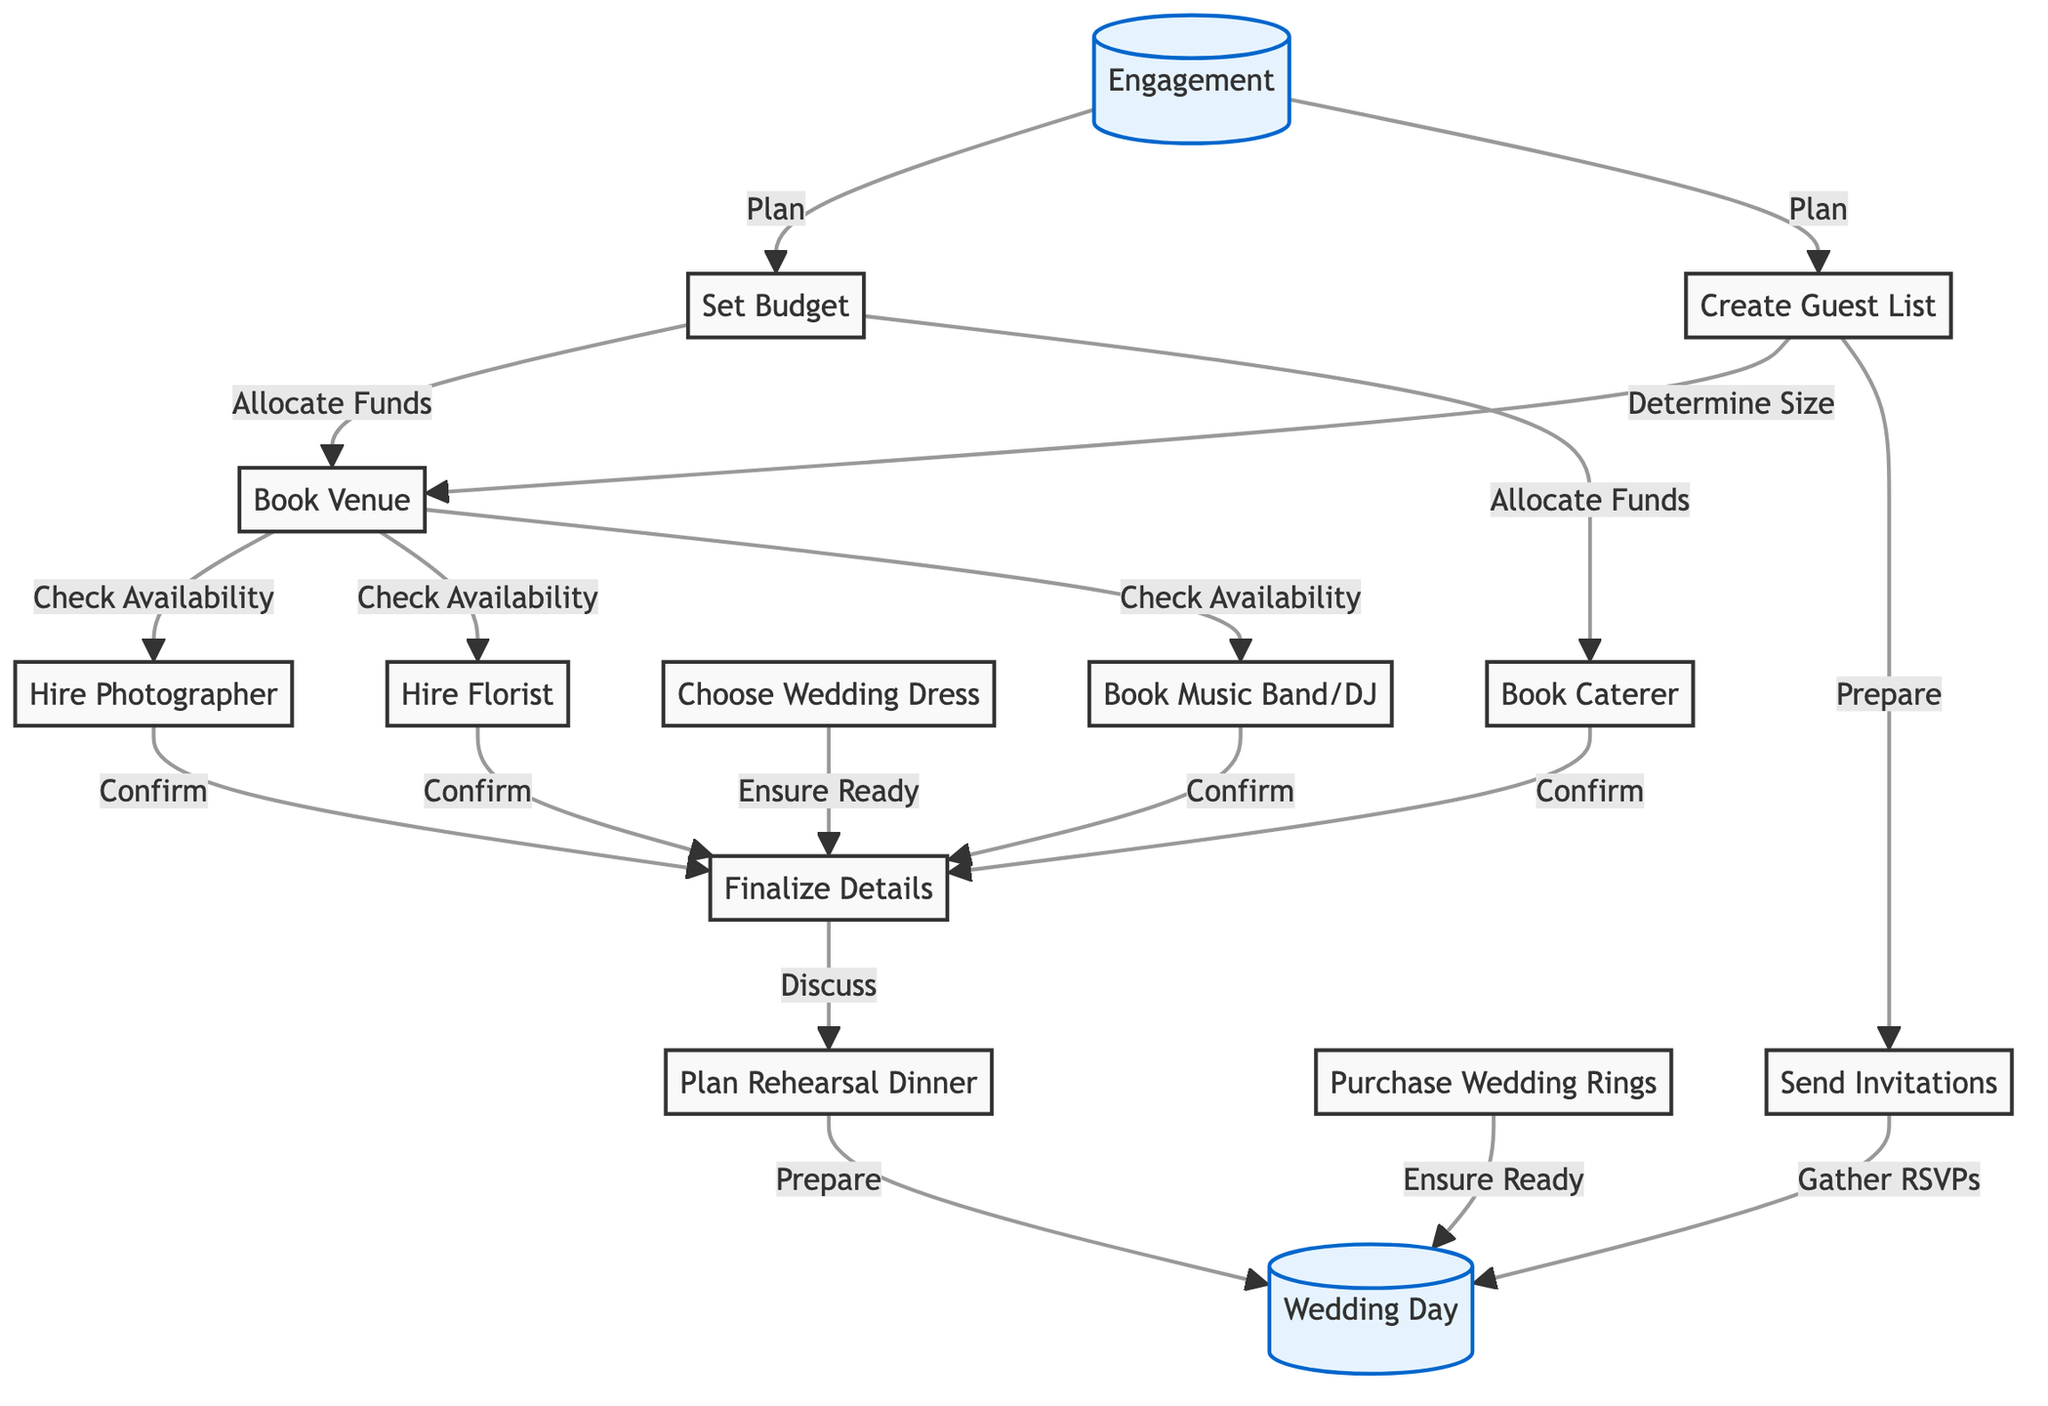What is the starting milestone for this timeline? The starting milestone, which is the first node in the directed graph, is "Engagement". This is identified as the entry point that leads to other planning steps in the diagram.
Answer: Engagement How many total nodes are in the diagram? To find the total number of nodes, we can count all the individual items listed under nodes, which are Engagement, Set Budget, Create Guest List, Book Venue, Hire Photographer, Book Caterer, Choose Wedding Dress, Send Invitations, Purchase Wedding Rings, Hire Florist, Book Music Band/DJ, Finalize Details, Plan Rehearsal Dinner, and Wedding Day, totaling 13 nodes.
Answer: 13 What links the "Set Budget" node to the "Book Venue" node? The label on the edge connecting "Set Budget" to "Book Venue" is "Allocate Funds". This connection indicates that one must allocate funds from the budget to book the venue.
Answer: Allocate Funds Which two nodes must be finalized before planning the Rehearsal Dinner? The nodes that must be finalized before planning the Rehearsal Dinner are "Finalize Details" and "Wedding Dress". "Finalize Details" is a prerequisite before the Rehearsal Dinner can be discussed, and the Wedding Dress must also be ensured ready.
Answer: Finalize Details, Wedding Dress What is the dependency between "Invitations" and "Wedding Day"? The dependency is expressed through the edge labeled "Gather RSVPs", indicating that the invitations need to be sent out, and the responses (RSVPs) must be gathered before the wedding day. This ensures that all guests have confirmed their attendance.
Answer: Gather RSVPs Which task cannot be started until the Venue is booked? The tasks that cannot be started until the Venue is booked include hiring the Photographer, hiring the Florist, and booking the Music Band/DJ. Each of these tasks has a direct edge from the Venue marked by "Check Availability", which confirms they depend on having a venue first.
Answer: Photographer, Florist, Music Band/DJ How many edges are in the diagram? To determine the total number of edges, we can simply count all connections that represent dependencies in the directed graph. In this graph, we find that there are 15 edges connecting the various nodes, representing the relationships and flow from one task to another in the wedding planning process.
Answer: 15 What is the last milestone in the timeline? The last milestone of this timeline is "Wedding Day", which is the culmination of all the planning activities leading up to this significant event. It is clearly marked as the final outcome in the directed graph.
Answer: Wedding Day 